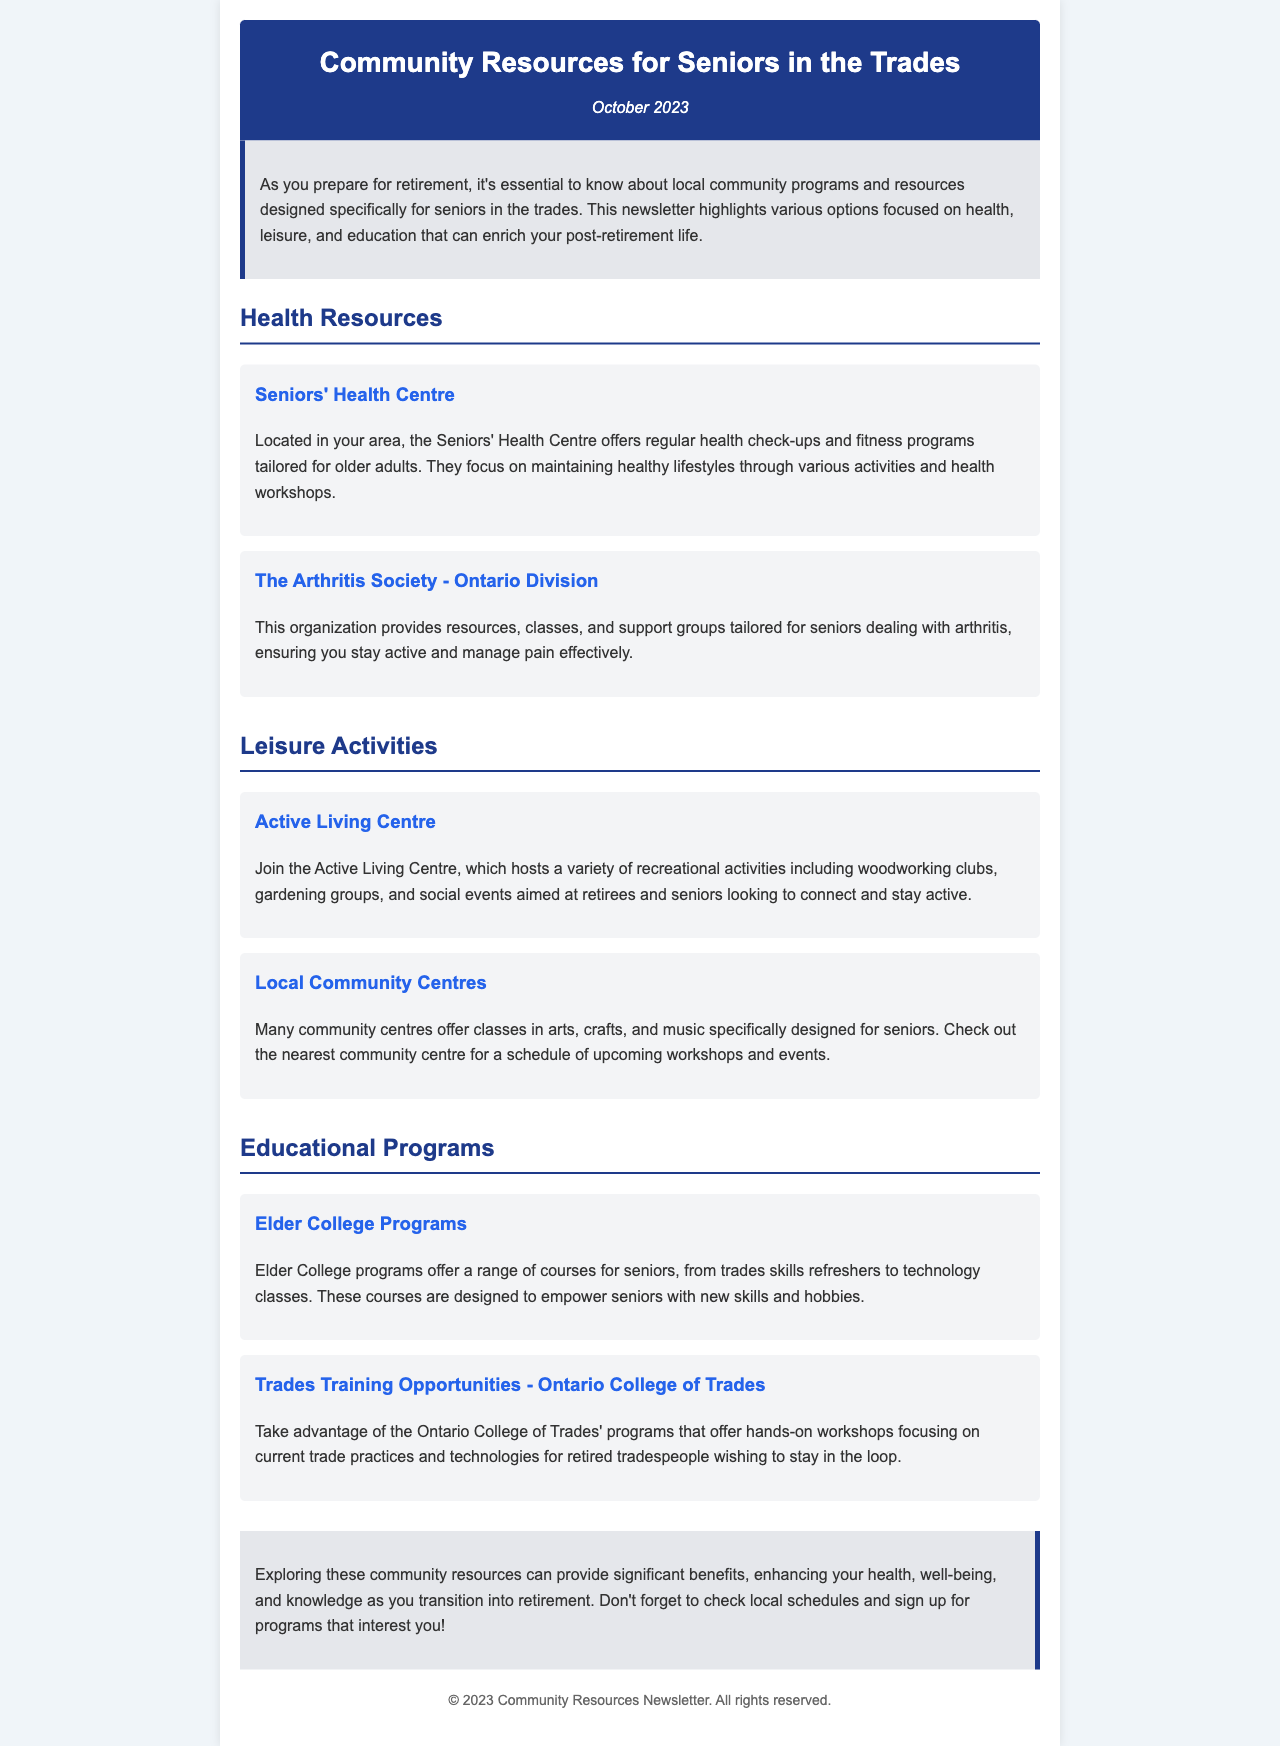What is the date of the newsletter? The date of the newsletter is mentioned at the top of the document, indicating its publication time.
Answer: October 2023 What health check-ups are offered? The document states that the Seniors' Health Centre offers regular health check-ups tailored for older adults.
Answer: Regular health check-ups What leisure activities are available at the Active Living Centre? The Active Living Centre hosts a variety of recreational activities including woodworking clubs, gardening groups, and social events for seniors.
Answer: Woodworking clubs, gardening groups, social events Which organization provides support groups for arthritis? The document provides the name of the organization that assists seniors dealing with arthritis.
Answer: The Arthritis Society - Ontario Division What type of programs do Elder College offer? The Elder College programs are described in the document, focusing on the type of courses available for seniors.
Answer: Range of courses for seniors How does the Ontario College of Trades support retired tradespeople? The document specifies the type of programs offered by the Ontario College of Trades to retired tradespeople.
Answer: Hands-on workshops focusing on current trade practices and technologies What is the main focus of the newsletter? The overall purpose of the newsletter is stated in the introductory paragraph.
Answer: Community programs and resources for seniors in the trades 